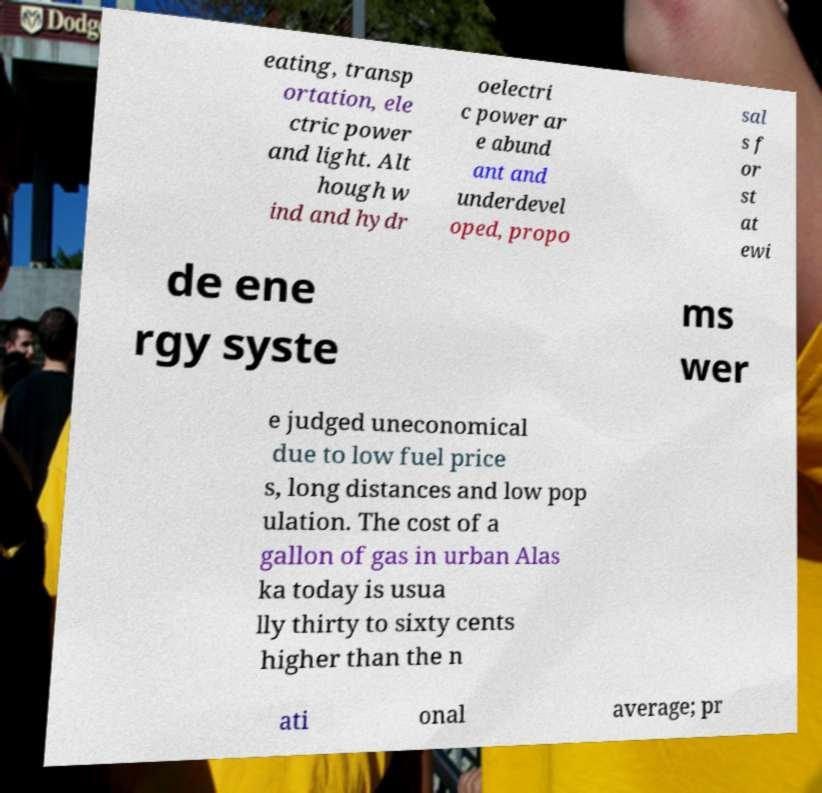There's text embedded in this image that I need extracted. Can you transcribe it verbatim? eating, transp ortation, ele ctric power and light. Alt hough w ind and hydr oelectri c power ar e abund ant and underdevel oped, propo sal s f or st at ewi de ene rgy syste ms wer e judged uneconomical due to low fuel price s, long distances and low pop ulation. The cost of a gallon of gas in urban Alas ka today is usua lly thirty to sixty cents higher than the n ati onal average; pr 